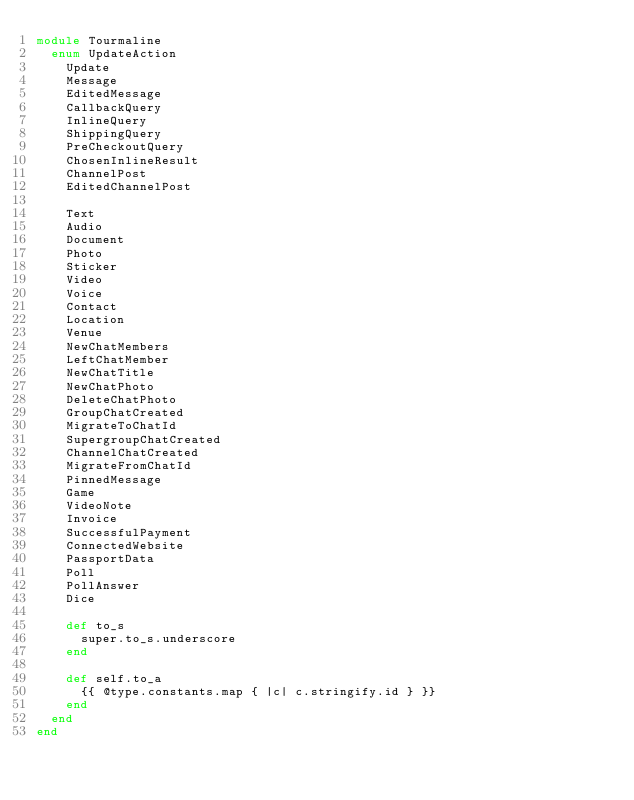<code> <loc_0><loc_0><loc_500><loc_500><_Crystal_>module Tourmaline
  enum UpdateAction
    Update
    Message
    EditedMessage
    CallbackQuery
    InlineQuery
    ShippingQuery
    PreCheckoutQuery
    ChosenInlineResult
    ChannelPost
    EditedChannelPost

    Text
    Audio
    Document
    Photo
    Sticker
    Video
    Voice
    Contact
    Location
    Venue
    NewChatMembers
    LeftChatMember
    NewChatTitle
    NewChatPhoto
    DeleteChatPhoto
    GroupChatCreated
    MigrateToChatId
    SupergroupChatCreated
    ChannelChatCreated
    MigrateFromChatId
    PinnedMessage
    Game
    VideoNote
    Invoice
    SuccessfulPayment
    ConnectedWebsite
    PassportData
    Poll
    PollAnswer
    Dice

    def to_s
      super.to_s.underscore
    end

    def self.to_a
      {{ @type.constants.map { |c| c.stringify.id } }}
    end
  end
end
</code> 